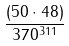<formula> <loc_0><loc_0><loc_500><loc_500>\frac { ( 5 0 \cdot 4 8 ) } { 3 7 0 ^ { 3 1 1 } }</formula> 